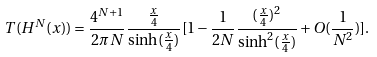Convert formula to latex. <formula><loc_0><loc_0><loc_500><loc_500>T ( H ^ { N } ( x ) ) = \frac { 4 ^ { N + 1 } } { 2 \pi N } \frac { \frac { x } { 4 } } { \sinh ( \frac { x } { 4 } ) } [ 1 - \frac { 1 } { 2 N } \frac { ( \frac { x } { 4 } ) ^ { 2 } } { \sinh ^ { 2 } ( \frac { x } { 4 } ) } + O ( \frac { 1 } { N ^ { 2 } } ) ] .</formula> 